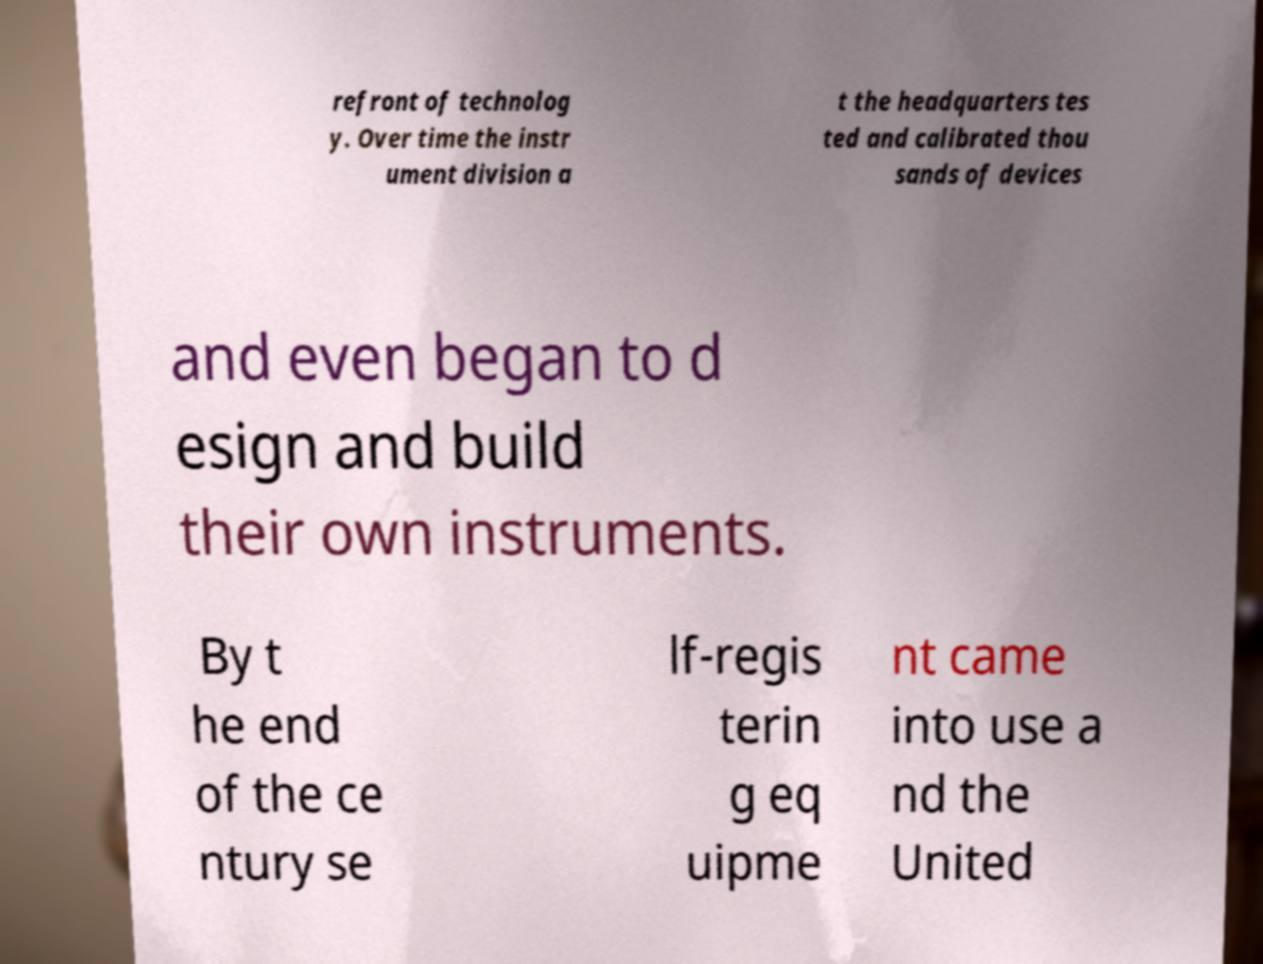Could you assist in decoding the text presented in this image and type it out clearly? refront of technolog y. Over time the instr ument division a t the headquarters tes ted and calibrated thou sands of devices and even began to d esign and build their own instruments. By t he end of the ce ntury se lf-regis terin g eq uipme nt came into use a nd the United 